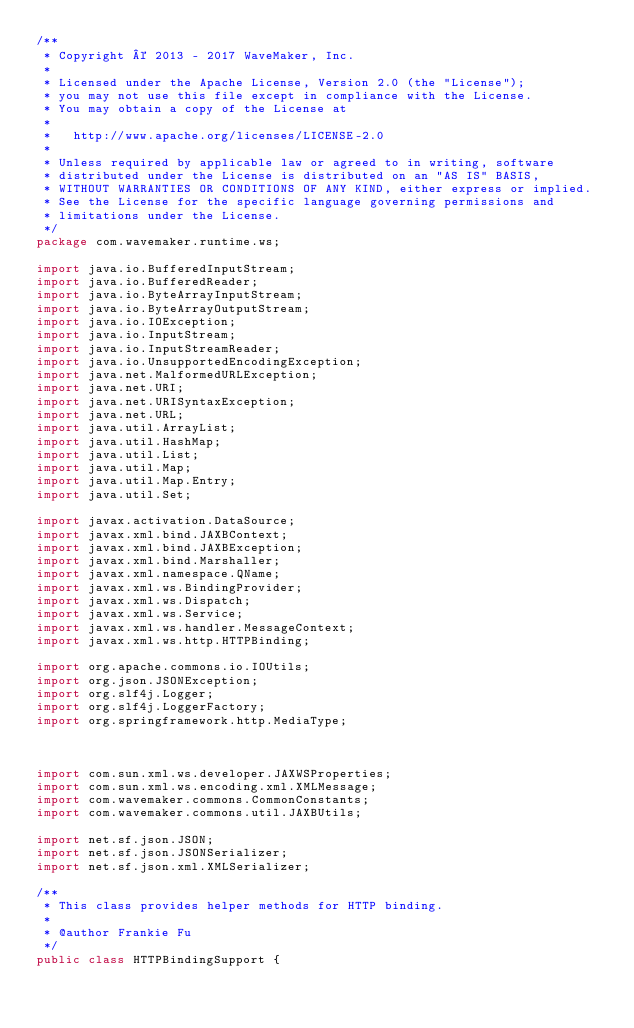<code> <loc_0><loc_0><loc_500><loc_500><_Java_>/**
 * Copyright © 2013 - 2017 WaveMaker, Inc.
 *
 * Licensed under the Apache License, Version 2.0 (the "License");
 * you may not use this file except in compliance with the License.
 * You may obtain a copy of the License at
 *
 *   http://www.apache.org/licenses/LICENSE-2.0
 *
 * Unless required by applicable law or agreed to in writing, software
 * distributed under the License is distributed on an "AS IS" BASIS,
 * WITHOUT WARRANTIES OR CONDITIONS OF ANY KIND, either express or implied.
 * See the License for the specific language governing permissions and
 * limitations under the License.
 */
package com.wavemaker.runtime.ws;

import java.io.BufferedInputStream;
import java.io.BufferedReader;
import java.io.ByteArrayInputStream;
import java.io.ByteArrayOutputStream;
import java.io.IOException;
import java.io.InputStream;
import java.io.InputStreamReader;
import java.io.UnsupportedEncodingException;
import java.net.MalformedURLException;
import java.net.URI;
import java.net.URISyntaxException;
import java.net.URL;
import java.util.ArrayList;
import java.util.HashMap;
import java.util.List;
import java.util.Map;
import java.util.Map.Entry;
import java.util.Set;

import javax.activation.DataSource;
import javax.xml.bind.JAXBContext;
import javax.xml.bind.JAXBException;
import javax.xml.bind.Marshaller;
import javax.xml.namespace.QName;
import javax.xml.ws.BindingProvider;
import javax.xml.ws.Dispatch;
import javax.xml.ws.Service;
import javax.xml.ws.handler.MessageContext;
import javax.xml.ws.http.HTTPBinding;

import org.apache.commons.io.IOUtils;
import org.json.JSONException;
import org.slf4j.Logger;
import org.slf4j.LoggerFactory;
import org.springframework.http.MediaType;



import com.sun.xml.ws.developer.JAXWSProperties;
import com.sun.xml.ws.encoding.xml.XMLMessage;
import com.wavemaker.commons.CommonConstants;
import com.wavemaker.commons.util.JAXBUtils;

import net.sf.json.JSON;
import net.sf.json.JSONSerializer;
import net.sf.json.xml.XMLSerializer;

/**
 * This class provides helper methods for HTTP binding.
 *
 * @author Frankie Fu
 */
public class HTTPBindingSupport {
</code> 